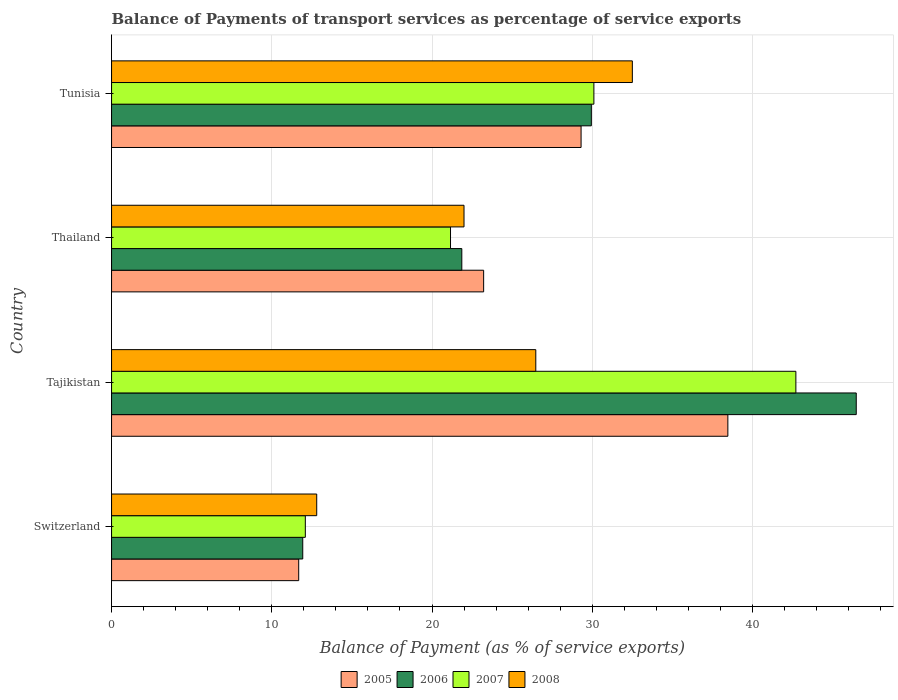How many different coloured bars are there?
Offer a terse response. 4. How many bars are there on the 3rd tick from the top?
Make the answer very short. 4. How many bars are there on the 1st tick from the bottom?
Give a very brief answer. 4. What is the label of the 2nd group of bars from the top?
Offer a terse response. Thailand. What is the balance of payments of transport services in 2005 in Switzerland?
Your response must be concise. 11.68. Across all countries, what is the maximum balance of payments of transport services in 2008?
Ensure brevity in your answer.  32.5. Across all countries, what is the minimum balance of payments of transport services in 2006?
Offer a very short reply. 11.93. In which country was the balance of payments of transport services in 2005 maximum?
Provide a succinct answer. Tajikistan. In which country was the balance of payments of transport services in 2008 minimum?
Provide a succinct answer. Switzerland. What is the total balance of payments of transport services in 2007 in the graph?
Your answer should be compact. 106.05. What is the difference between the balance of payments of transport services in 2007 in Switzerland and that in Thailand?
Ensure brevity in your answer.  -9.06. What is the difference between the balance of payments of transport services in 2005 in Tajikistan and the balance of payments of transport services in 2008 in Thailand?
Ensure brevity in your answer.  16.47. What is the average balance of payments of transport services in 2005 per country?
Give a very brief answer. 25.67. What is the difference between the balance of payments of transport services in 2007 and balance of payments of transport services in 2006 in Switzerland?
Your response must be concise. 0.16. What is the ratio of the balance of payments of transport services in 2007 in Thailand to that in Tunisia?
Provide a short and direct response. 0.7. Is the balance of payments of transport services in 2006 in Switzerland less than that in Thailand?
Ensure brevity in your answer.  Yes. What is the difference between the highest and the second highest balance of payments of transport services in 2005?
Keep it short and to the point. 9.16. What is the difference between the highest and the lowest balance of payments of transport services in 2006?
Your answer should be very brief. 34.54. What does the 1st bar from the top in Tajikistan represents?
Make the answer very short. 2008. What does the 4th bar from the bottom in Tajikistan represents?
Keep it short and to the point. 2008. How many countries are there in the graph?
Your answer should be very brief. 4. What is the difference between two consecutive major ticks on the X-axis?
Ensure brevity in your answer.  10. Are the values on the major ticks of X-axis written in scientific E-notation?
Ensure brevity in your answer.  No. Does the graph contain any zero values?
Provide a succinct answer. No. How are the legend labels stacked?
Provide a succinct answer. Horizontal. What is the title of the graph?
Your response must be concise. Balance of Payments of transport services as percentage of service exports. Does "2014" appear as one of the legend labels in the graph?
Offer a terse response. No. What is the label or title of the X-axis?
Your answer should be compact. Balance of Payment (as % of service exports). What is the label or title of the Y-axis?
Give a very brief answer. Country. What is the Balance of Payment (as % of service exports) in 2005 in Switzerland?
Ensure brevity in your answer.  11.68. What is the Balance of Payment (as % of service exports) in 2006 in Switzerland?
Provide a succinct answer. 11.93. What is the Balance of Payment (as % of service exports) in 2007 in Switzerland?
Offer a terse response. 12.09. What is the Balance of Payment (as % of service exports) of 2008 in Switzerland?
Provide a succinct answer. 12.8. What is the Balance of Payment (as % of service exports) of 2005 in Tajikistan?
Your response must be concise. 38.46. What is the Balance of Payment (as % of service exports) in 2006 in Tajikistan?
Your answer should be compact. 46.47. What is the Balance of Payment (as % of service exports) of 2007 in Tajikistan?
Your answer should be compact. 42.71. What is the Balance of Payment (as % of service exports) of 2008 in Tajikistan?
Offer a very short reply. 26.47. What is the Balance of Payment (as % of service exports) in 2005 in Thailand?
Ensure brevity in your answer.  23.22. What is the Balance of Payment (as % of service exports) of 2006 in Thailand?
Your response must be concise. 21.86. What is the Balance of Payment (as % of service exports) of 2007 in Thailand?
Provide a short and direct response. 21.15. What is the Balance of Payment (as % of service exports) in 2008 in Thailand?
Offer a terse response. 22. What is the Balance of Payment (as % of service exports) in 2005 in Tunisia?
Offer a very short reply. 29.3. What is the Balance of Payment (as % of service exports) in 2006 in Tunisia?
Your response must be concise. 29.94. What is the Balance of Payment (as % of service exports) of 2007 in Tunisia?
Your answer should be compact. 30.1. What is the Balance of Payment (as % of service exports) in 2008 in Tunisia?
Give a very brief answer. 32.5. Across all countries, what is the maximum Balance of Payment (as % of service exports) of 2005?
Keep it short and to the point. 38.46. Across all countries, what is the maximum Balance of Payment (as % of service exports) of 2006?
Give a very brief answer. 46.47. Across all countries, what is the maximum Balance of Payment (as % of service exports) of 2007?
Ensure brevity in your answer.  42.71. Across all countries, what is the maximum Balance of Payment (as % of service exports) of 2008?
Your answer should be very brief. 32.5. Across all countries, what is the minimum Balance of Payment (as % of service exports) of 2005?
Offer a very short reply. 11.68. Across all countries, what is the minimum Balance of Payment (as % of service exports) of 2006?
Your answer should be compact. 11.93. Across all countries, what is the minimum Balance of Payment (as % of service exports) of 2007?
Ensure brevity in your answer.  12.09. Across all countries, what is the minimum Balance of Payment (as % of service exports) in 2008?
Your response must be concise. 12.8. What is the total Balance of Payment (as % of service exports) of 2005 in the graph?
Give a very brief answer. 102.66. What is the total Balance of Payment (as % of service exports) in 2006 in the graph?
Provide a succinct answer. 110.21. What is the total Balance of Payment (as % of service exports) in 2007 in the graph?
Give a very brief answer. 106.05. What is the total Balance of Payment (as % of service exports) of 2008 in the graph?
Keep it short and to the point. 93.77. What is the difference between the Balance of Payment (as % of service exports) of 2005 in Switzerland and that in Tajikistan?
Your answer should be compact. -26.78. What is the difference between the Balance of Payment (as % of service exports) of 2006 in Switzerland and that in Tajikistan?
Provide a succinct answer. -34.54. What is the difference between the Balance of Payment (as % of service exports) of 2007 in Switzerland and that in Tajikistan?
Offer a terse response. -30.61. What is the difference between the Balance of Payment (as % of service exports) of 2008 in Switzerland and that in Tajikistan?
Make the answer very short. -13.67. What is the difference between the Balance of Payment (as % of service exports) in 2005 in Switzerland and that in Thailand?
Keep it short and to the point. -11.54. What is the difference between the Balance of Payment (as % of service exports) in 2006 in Switzerland and that in Thailand?
Offer a terse response. -9.93. What is the difference between the Balance of Payment (as % of service exports) of 2007 in Switzerland and that in Thailand?
Offer a very short reply. -9.06. What is the difference between the Balance of Payment (as % of service exports) of 2008 in Switzerland and that in Thailand?
Offer a very short reply. -9.19. What is the difference between the Balance of Payment (as % of service exports) of 2005 in Switzerland and that in Tunisia?
Provide a succinct answer. -17.62. What is the difference between the Balance of Payment (as % of service exports) in 2006 in Switzerland and that in Tunisia?
Your response must be concise. -18.01. What is the difference between the Balance of Payment (as % of service exports) of 2007 in Switzerland and that in Tunisia?
Offer a terse response. -18.01. What is the difference between the Balance of Payment (as % of service exports) of 2008 in Switzerland and that in Tunisia?
Your answer should be compact. -19.7. What is the difference between the Balance of Payment (as % of service exports) in 2005 in Tajikistan and that in Thailand?
Your answer should be very brief. 15.24. What is the difference between the Balance of Payment (as % of service exports) in 2006 in Tajikistan and that in Thailand?
Ensure brevity in your answer.  24.62. What is the difference between the Balance of Payment (as % of service exports) of 2007 in Tajikistan and that in Thailand?
Ensure brevity in your answer.  21.55. What is the difference between the Balance of Payment (as % of service exports) in 2008 in Tajikistan and that in Thailand?
Offer a very short reply. 4.48. What is the difference between the Balance of Payment (as % of service exports) of 2005 in Tajikistan and that in Tunisia?
Provide a short and direct response. 9.16. What is the difference between the Balance of Payment (as % of service exports) in 2006 in Tajikistan and that in Tunisia?
Your answer should be compact. 16.53. What is the difference between the Balance of Payment (as % of service exports) in 2007 in Tajikistan and that in Tunisia?
Your answer should be very brief. 12.6. What is the difference between the Balance of Payment (as % of service exports) of 2008 in Tajikistan and that in Tunisia?
Keep it short and to the point. -6.03. What is the difference between the Balance of Payment (as % of service exports) in 2005 in Thailand and that in Tunisia?
Provide a succinct answer. -6.08. What is the difference between the Balance of Payment (as % of service exports) in 2006 in Thailand and that in Tunisia?
Give a very brief answer. -8.08. What is the difference between the Balance of Payment (as % of service exports) of 2007 in Thailand and that in Tunisia?
Your answer should be very brief. -8.95. What is the difference between the Balance of Payment (as % of service exports) of 2008 in Thailand and that in Tunisia?
Offer a very short reply. -10.51. What is the difference between the Balance of Payment (as % of service exports) in 2005 in Switzerland and the Balance of Payment (as % of service exports) in 2006 in Tajikistan?
Offer a very short reply. -34.8. What is the difference between the Balance of Payment (as % of service exports) of 2005 in Switzerland and the Balance of Payment (as % of service exports) of 2007 in Tajikistan?
Offer a very short reply. -31.03. What is the difference between the Balance of Payment (as % of service exports) in 2005 in Switzerland and the Balance of Payment (as % of service exports) in 2008 in Tajikistan?
Your response must be concise. -14.8. What is the difference between the Balance of Payment (as % of service exports) of 2006 in Switzerland and the Balance of Payment (as % of service exports) of 2007 in Tajikistan?
Provide a short and direct response. -30.77. What is the difference between the Balance of Payment (as % of service exports) in 2006 in Switzerland and the Balance of Payment (as % of service exports) in 2008 in Tajikistan?
Your answer should be very brief. -14.54. What is the difference between the Balance of Payment (as % of service exports) in 2007 in Switzerland and the Balance of Payment (as % of service exports) in 2008 in Tajikistan?
Provide a succinct answer. -14.38. What is the difference between the Balance of Payment (as % of service exports) of 2005 in Switzerland and the Balance of Payment (as % of service exports) of 2006 in Thailand?
Make the answer very short. -10.18. What is the difference between the Balance of Payment (as % of service exports) in 2005 in Switzerland and the Balance of Payment (as % of service exports) in 2007 in Thailand?
Keep it short and to the point. -9.47. What is the difference between the Balance of Payment (as % of service exports) of 2005 in Switzerland and the Balance of Payment (as % of service exports) of 2008 in Thailand?
Your response must be concise. -10.32. What is the difference between the Balance of Payment (as % of service exports) in 2006 in Switzerland and the Balance of Payment (as % of service exports) in 2007 in Thailand?
Provide a short and direct response. -9.22. What is the difference between the Balance of Payment (as % of service exports) of 2006 in Switzerland and the Balance of Payment (as % of service exports) of 2008 in Thailand?
Keep it short and to the point. -10.06. What is the difference between the Balance of Payment (as % of service exports) of 2007 in Switzerland and the Balance of Payment (as % of service exports) of 2008 in Thailand?
Offer a very short reply. -9.9. What is the difference between the Balance of Payment (as % of service exports) in 2005 in Switzerland and the Balance of Payment (as % of service exports) in 2006 in Tunisia?
Keep it short and to the point. -18.26. What is the difference between the Balance of Payment (as % of service exports) of 2005 in Switzerland and the Balance of Payment (as % of service exports) of 2007 in Tunisia?
Your response must be concise. -18.42. What is the difference between the Balance of Payment (as % of service exports) of 2005 in Switzerland and the Balance of Payment (as % of service exports) of 2008 in Tunisia?
Provide a succinct answer. -20.82. What is the difference between the Balance of Payment (as % of service exports) of 2006 in Switzerland and the Balance of Payment (as % of service exports) of 2007 in Tunisia?
Your response must be concise. -18.17. What is the difference between the Balance of Payment (as % of service exports) of 2006 in Switzerland and the Balance of Payment (as % of service exports) of 2008 in Tunisia?
Your answer should be very brief. -20.57. What is the difference between the Balance of Payment (as % of service exports) in 2007 in Switzerland and the Balance of Payment (as % of service exports) in 2008 in Tunisia?
Your answer should be very brief. -20.41. What is the difference between the Balance of Payment (as % of service exports) of 2005 in Tajikistan and the Balance of Payment (as % of service exports) of 2006 in Thailand?
Ensure brevity in your answer.  16.6. What is the difference between the Balance of Payment (as % of service exports) in 2005 in Tajikistan and the Balance of Payment (as % of service exports) in 2007 in Thailand?
Give a very brief answer. 17.31. What is the difference between the Balance of Payment (as % of service exports) of 2005 in Tajikistan and the Balance of Payment (as % of service exports) of 2008 in Thailand?
Provide a succinct answer. 16.47. What is the difference between the Balance of Payment (as % of service exports) in 2006 in Tajikistan and the Balance of Payment (as % of service exports) in 2007 in Thailand?
Give a very brief answer. 25.32. What is the difference between the Balance of Payment (as % of service exports) in 2006 in Tajikistan and the Balance of Payment (as % of service exports) in 2008 in Thailand?
Provide a short and direct response. 24.48. What is the difference between the Balance of Payment (as % of service exports) in 2007 in Tajikistan and the Balance of Payment (as % of service exports) in 2008 in Thailand?
Keep it short and to the point. 20.71. What is the difference between the Balance of Payment (as % of service exports) of 2005 in Tajikistan and the Balance of Payment (as % of service exports) of 2006 in Tunisia?
Your response must be concise. 8.52. What is the difference between the Balance of Payment (as % of service exports) of 2005 in Tajikistan and the Balance of Payment (as % of service exports) of 2007 in Tunisia?
Keep it short and to the point. 8.36. What is the difference between the Balance of Payment (as % of service exports) of 2005 in Tajikistan and the Balance of Payment (as % of service exports) of 2008 in Tunisia?
Keep it short and to the point. 5.96. What is the difference between the Balance of Payment (as % of service exports) of 2006 in Tajikistan and the Balance of Payment (as % of service exports) of 2007 in Tunisia?
Offer a terse response. 16.37. What is the difference between the Balance of Payment (as % of service exports) of 2006 in Tajikistan and the Balance of Payment (as % of service exports) of 2008 in Tunisia?
Offer a terse response. 13.97. What is the difference between the Balance of Payment (as % of service exports) in 2007 in Tajikistan and the Balance of Payment (as % of service exports) in 2008 in Tunisia?
Provide a short and direct response. 10.21. What is the difference between the Balance of Payment (as % of service exports) in 2005 in Thailand and the Balance of Payment (as % of service exports) in 2006 in Tunisia?
Give a very brief answer. -6.72. What is the difference between the Balance of Payment (as % of service exports) in 2005 in Thailand and the Balance of Payment (as % of service exports) in 2007 in Tunisia?
Provide a short and direct response. -6.88. What is the difference between the Balance of Payment (as % of service exports) in 2005 in Thailand and the Balance of Payment (as % of service exports) in 2008 in Tunisia?
Offer a terse response. -9.28. What is the difference between the Balance of Payment (as % of service exports) in 2006 in Thailand and the Balance of Payment (as % of service exports) in 2007 in Tunisia?
Make the answer very short. -8.24. What is the difference between the Balance of Payment (as % of service exports) of 2006 in Thailand and the Balance of Payment (as % of service exports) of 2008 in Tunisia?
Make the answer very short. -10.64. What is the difference between the Balance of Payment (as % of service exports) in 2007 in Thailand and the Balance of Payment (as % of service exports) in 2008 in Tunisia?
Offer a terse response. -11.35. What is the average Balance of Payment (as % of service exports) in 2005 per country?
Provide a succinct answer. 25.67. What is the average Balance of Payment (as % of service exports) in 2006 per country?
Offer a terse response. 27.55. What is the average Balance of Payment (as % of service exports) in 2007 per country?
Your answer should be very brief. 26.51. What is the average Balance of Payment (as % of service exports) in 2008 per country?
Provide a succinct answer. 23.44. What is the difference between the Balance of Payment (as % of service exports) in 2005 and Balance of Payment (as % of service exports) in 2006 in Switzerland?
Offer a terse response. -0.25. What is the difference between the Balance of Payment (as % of service exports) of 2005 and Balance of Payment (as % of service exports) of 2007 in Switzerland?
Your answer should be compact. -0.41. What is the difference between the Balance of Payment (as % of service exports) in 2005 and Balance of Payment (as % of service exports) in 2008 in Switzerland?
Ensure brevity in your answer.  -1.12. What is the difference between the Balance of Payment (as % of service exports) in 2006 and Balance of Payment (as % of service exports) in 2007 in Switzerland?
Your response must be concise. -0.16. What is the difference between the Balance of Payment (as % of service exports) in 2006 and Balance of Payment (as % of service exports) in 2008 in Switzerland?
Make the answer very short. -0.87. What is the difference between the Balance of Payment (as % of service exports) of 2007 and Balance of Payment (as % of service exports) of 2008 in Switzerland?
Make the answer very short. -0.71. What is the difference between the Balance of Payment (as % of service exports) in 2005 and Balance of Payment (as % of service exports) in 2006 in Tajikistan?
Provide a short and direct response. -8.01. What is the difference between the Balance of Payment (as % of service exports) in 2005 and Balance of Payment (as % of service exports) in 2007 in Tajikistan?
Ensure brevity in your answer.  -4.24. What is the difference between the Balance of Payment (as % of service exports) of 2005 and Balance of Payment (as % of service exports) of 2008 in Tajikistan?
Your answer should be compact. 11.99. What is the difference between the Balance of Payment (as % of service exports) in 2006 and Balance of Payment (as % of service exports) in 2007 in Tajikistan?
Ensure brevity in your answer.  3.77. What is the difference between the Balance of Payment (as % of service exports) in 2006 and Balance of Payment (as % of service exports) in 2008 in Tajikistan?
Offer a very short reply. 20. What is the difference between the Balance of Payment (as % of service exports) in 2007 and Balance of Payment (as % of service exports) in 2008 in Tajikistan?
Your answer should be very brief. 16.23. What is the difference between the Balance of Payment (as % of service exports) of 2005 and Balance of Payment (as % of service exports) of 2006 in Thailand?
Your answer should be compact. 1.36. What is the difference between the Balance of Payment (as % of service exports) of 2005 and Balance of Payment (as % of service exports) of 2007 in Thailand?
Your answer should be compact. 2.07. What is the difference between the Balance of Payment (as % of service exports) of 2005 and Balance of Payment (as % of service exports) of 2008 in Thailand?
Ensure brevity in your answer.  1.23. What is the difference between the Balance of Payment (as % of service exports) in 2006 and Balance of Payment (as % of service exports) in 2007 in Thailand?
Keep it short and to the point. 0.7. What is the difference between the Balance of Payment (as % of service exports) in 2006 and Balance of Payment (as % of service exports) in 2008 in Thailand?
Make the answer very short. -0.14. What is the difference between the Balance of Payment (as % of service exports) in 2007 and Balance of Payment (as % of service exports) in 2008 in Thailand?
Your answer should be very brief. -0.84. What is the difference between the Balance of Payment (as % of service exports) of 2005 and Balance of Payment (as % of service exports) of 2006 in Tunisia?
Ensure brevity in your answer.  -0.64. What is the difference between the Balance of Payment (as % of service exports) of 2005 and Balance of Payment (as % of service exports) of 2008 in Tunisia?
Give a very brief answer. -3.2. What is the difference between the Balance of Payment (as % of service exports) of 2006 and Balance of Payment (as % of service exports) of 2007 in Tunisia?
Give a very brief answer. -0.16. What is the difference between the Balance of Payment (as % of service exports) in 2006 and Balance of Payment (as % of service exports) in 2008 in Tunisia?
Your response must be concise. -2.56. What is the difference between the Balance of Payment (as % of service exports) of 2007 and Balance of Payment (as % of service exports) of 2008 in Tunisia?
Your response must be concise. -2.4. What is the ratio of the Balance of Payment (as % of service exports) in 2005 in Switzerland to that in Tajikistan?
Offer a very short reply. 0.3. What is the ratio of the Balance of Payment (as % of service exports) of 2006 in Switzerland to that in Tajikistan?
Your answer should be compact. 0.26. What is the ratio of the Balance of Payment (as % of service exports) of 2007 in Switzerland to that in Tajikistan?
Offer a terse response. 0.28. What is the ratio of the Balance of Payment (as % of service exports) of 2008 in Switzerland to that in Tajikistan?
Keep it short and to the point. 0.48. What is the ratio of the Balance of Payment (as % of service exports) in 2005 in Switzerland to that in Thailand?
Give a very brief answer. 0.5. What is the ratio of the Balance of Payment (as % of service exports) in 2006 in Switzerland to that in Thailand?
Offer a very short reply. 0.55. What is the ratio of the Balance of Payment (as % of service exports) of 2007 in Switzerland to that in Thailand?
Ensure brevity in your answer.  0.57. What is the ratio of the Balance of Payment (as % of service exports) of 2008 in Switzerland to that in Thailand?
Make the answer very short. 0.58. What is the ratio of the Balance of Payment (as % of service exports) of 2005 in Switzerland to that in Tunisia?
Offer a terse response. 0.4. What is the ratio of the Balance of Payment (as % of service exports) in 2006 in Switzerland to that in Tunisia?
Provide a succinct answer. 0.4. What is the ratio of the Balance of Payment (as % of service exports) in 2007 in Switzerland to that in Tunisia?
Your response must be concise. 0.4. What is the ratio of the Balance of Payment (as % of service exports) in 2008 in Switzerland to that in Tunisia?
Make the answer very short. 0.39. What is the ratio of the Balance of Payment (as % of service exports) in 2005 in Tajikistan to that in Thailand?
Give a very brief answer. 1.66. What is the ratio of the Balance of Payment (as % of service exports) in 2006 in Tajikistan to that in Thailand?
Provide a succinct answer. 2.13. What is the ratio of the Balance of Payment (as % of service exports) of 2007 in Tajikistan to that in Thailand?
Your answer should be very brief. 2.02. What is the ratio of the Balance of Payment (as % of service exports) in 2008 in Tajikistan to that in Thailand?
Give a very brief answer. 1.2. What is the ratio of the Balance of Payment (as % of service exports) in 2005 in Tajikistan to that in Tunisia?
Your response must be concise. 1.31. What is the ratio of the Balance of Payment (as % of service exports) in 2006 in Tajikistan to that in Tunisia?
Make the answer very short. 1.55. What is the ratio of the Balance of Payment (as % of service exports) in 2007 in Tajikistan to that in Tunisia?
Give a very brief answer. 1.42. What is the ratio of the Balance of Payment (as % of service exports) in 2008 in Tajikistan to that in Tunisia?
Keep it short and to the point. 0.81. What is the ratio of the Balance of Payment (as % of service exports) of 2005 in Thailand to that in Tunisia?
Provide a short and direct response. 0.79. What is the ratio of the Balance of Payment (as % of service exports) in 2006 in Thailand to that in Tunisia?
Provide a short and direct response. 0.73. What is the ratio of the Balance of Payment (as % of service exports) in 2007 in Thailand to that in Tunisia?
Your answer should be very brief. 0.7. What is the ratio of the Balance of Payment (as % of service exports) of 2008 in Thailand to that in Tunisia?
Offer a terse response. 0.68. What is the difference between the highest and the second highest Balance of Payment (as % of service exports) of 2005?
Offer a very short reply. 9.16. What is the difference between the highest and the second highest Balance of Payment (as % of service exports) in 2006?
Give a very brief answer. 16.53. What is the difference between the highest and the second highest Balance of Payment (as % of service exports) in 2007?
Your response must be concise. 12.6. What is the difference between the highest and the second highest Balance of Payment (as % of service exports) in 2008?
Keep it short and to the point. 6.03. What is the difference between the highest and the lowest Balance of Payment (as % of service exports) in 2005?
Give a very brief answer. 26.78. What is the difference between the highest and the lowest Balance of Payment (as % of service exports) of 2006?
Offer a very short reply. 34.54. What is the difference between the highest and the lowest Balance of Payment (as % of service exports) of 2007?
Keep it short and to the point. 30.61. What is the difference between the highest and the lowest Balance of Payment (as % of service exports) in 2008?
Offer a very short reply. 19.7. 